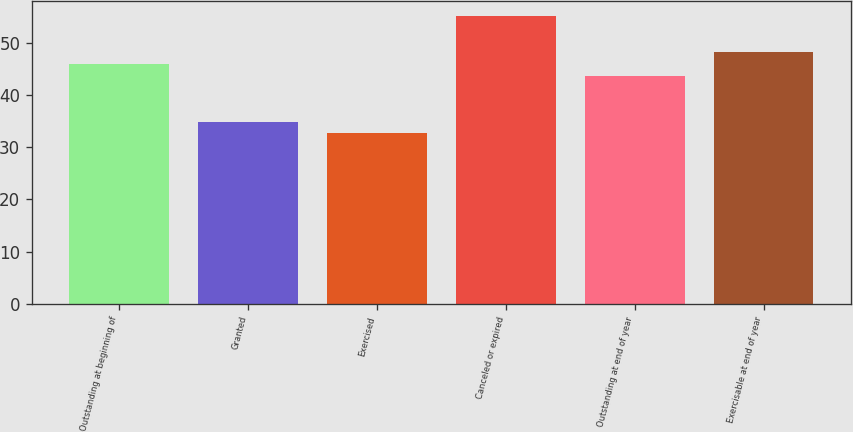<chart> <loc_0><loc_0><loc_500><loc_500><bar_chart><fcel>Outstanding at beginning of<fcel>Granted<fcel>Exercised<fcel>Canceled or expired<fcel>Outstanding at end of year<fcel>Exercisable at end of year<nl><fcel>45.94<fcel>34.9<fcel>32.64<fcel>55.2<fcel>43.68<fcel>48.2<nl></chart> 